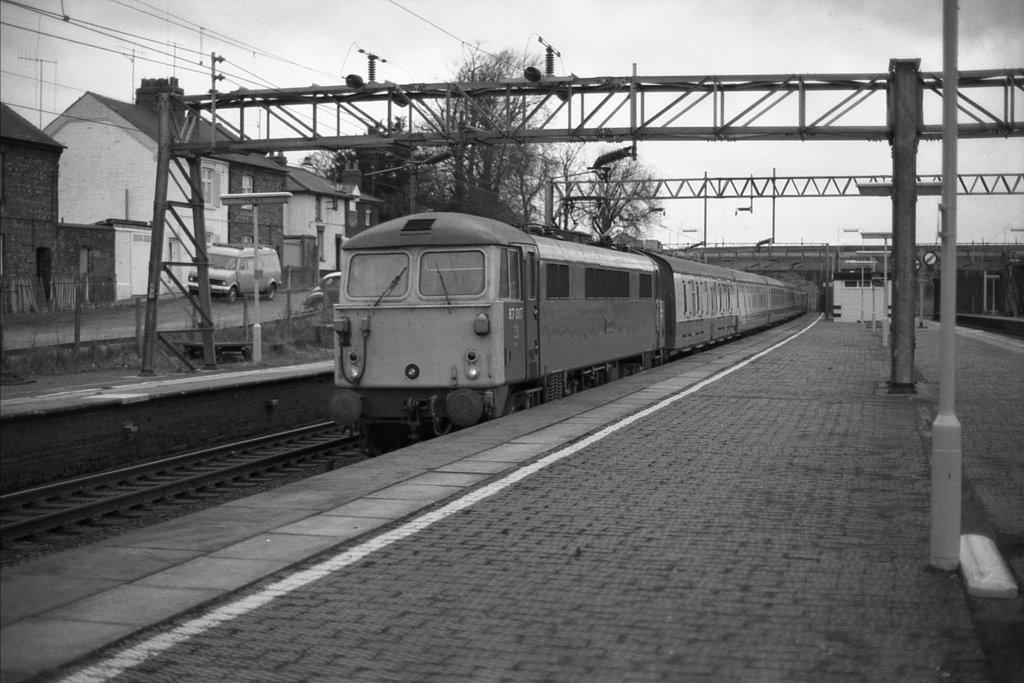Can you describe this image briefly? This is a black and white image and here we can see a train on the track and in the background, there is a grill and we can see buildings and some vehicles and there are trees and there is a bridge. At the bottom, there is road. 